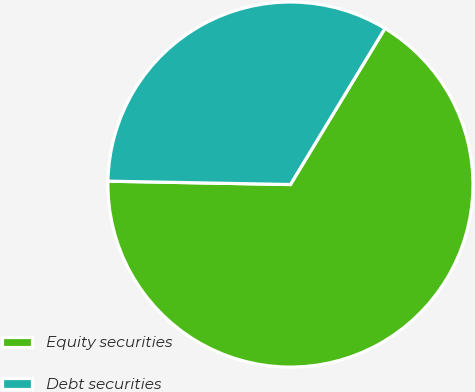<chart> <loc_0><loc_0><loc_500><loc_500><pie_chart><fcel>Equity securities<fcel>Debt securities<nl><fcel>66.63%<fcel>33.37%<nl></chart> 